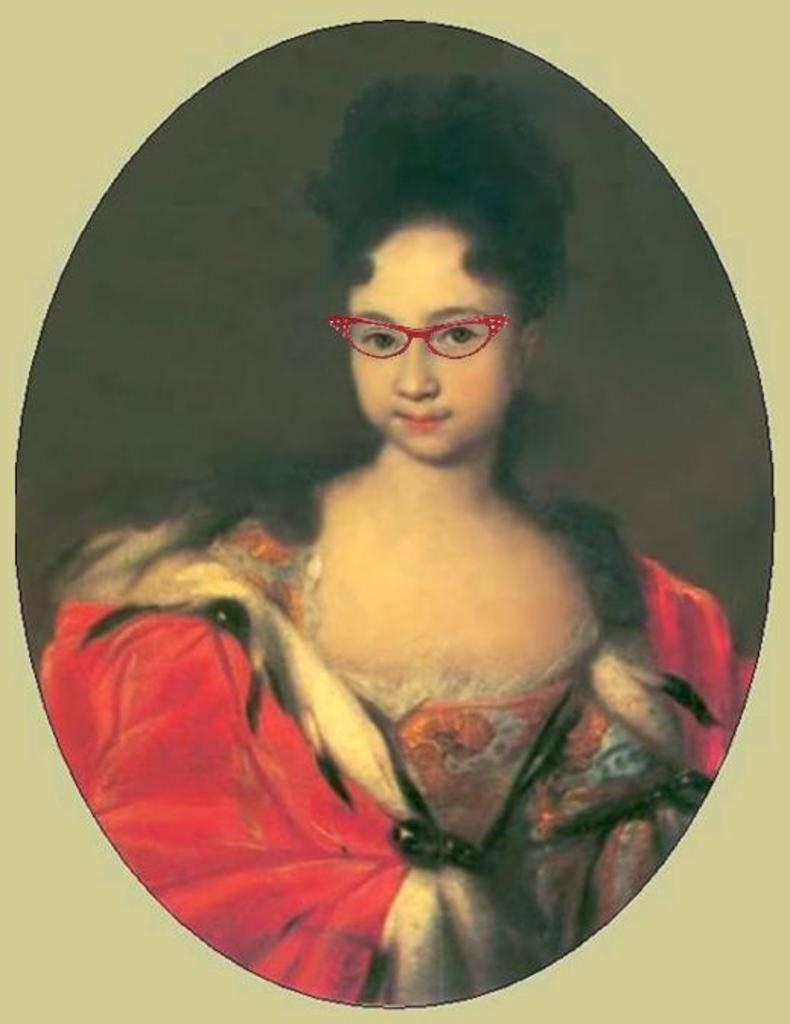Who is the main subject in the image? There is a girl in the image. What is the girl wearing? The girl is wearing a red dress and red color spectacles. Can you describe the girl's hair? The girl has short and black hair. What type of clouds can be seen in the image? There are no clouds visible in the image, as it features a girl wearing a red dress and red color spectacles. 